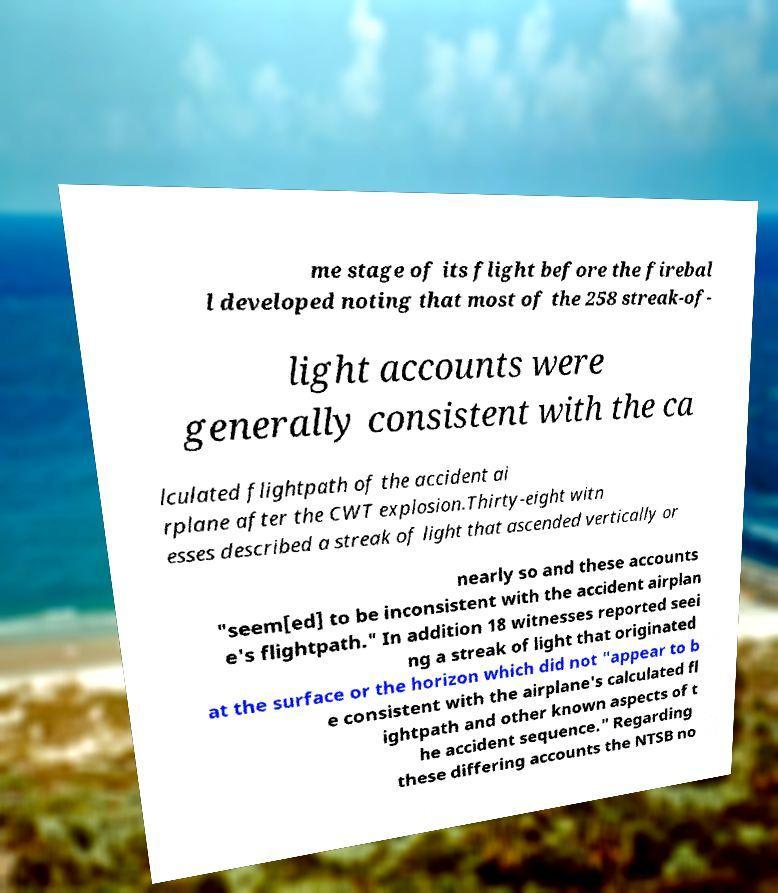What messages or text are displayed in this image? I need them in a readable, typed format. me stage of its flight before the firebal l developed noting that most of the 258 streak-of- light accounts were generally consistent with the ca lculated flightpath of the accident ai rplane after the CWT explosion.Thirty-eight witn esses described a streak of light that ascended vertically or nearly so and these accounts "seem[ed] to be inconsistent with the accident airplan e's flightpath." In addition 18 witnesses reported seei ng a streak of light that originated at the surface or the horizon which did not "appear to b e consistent with the airplane's calculated fl ightpath and other known aspects of t he accident sequence." Regarding these differing accounts the NTSB no 